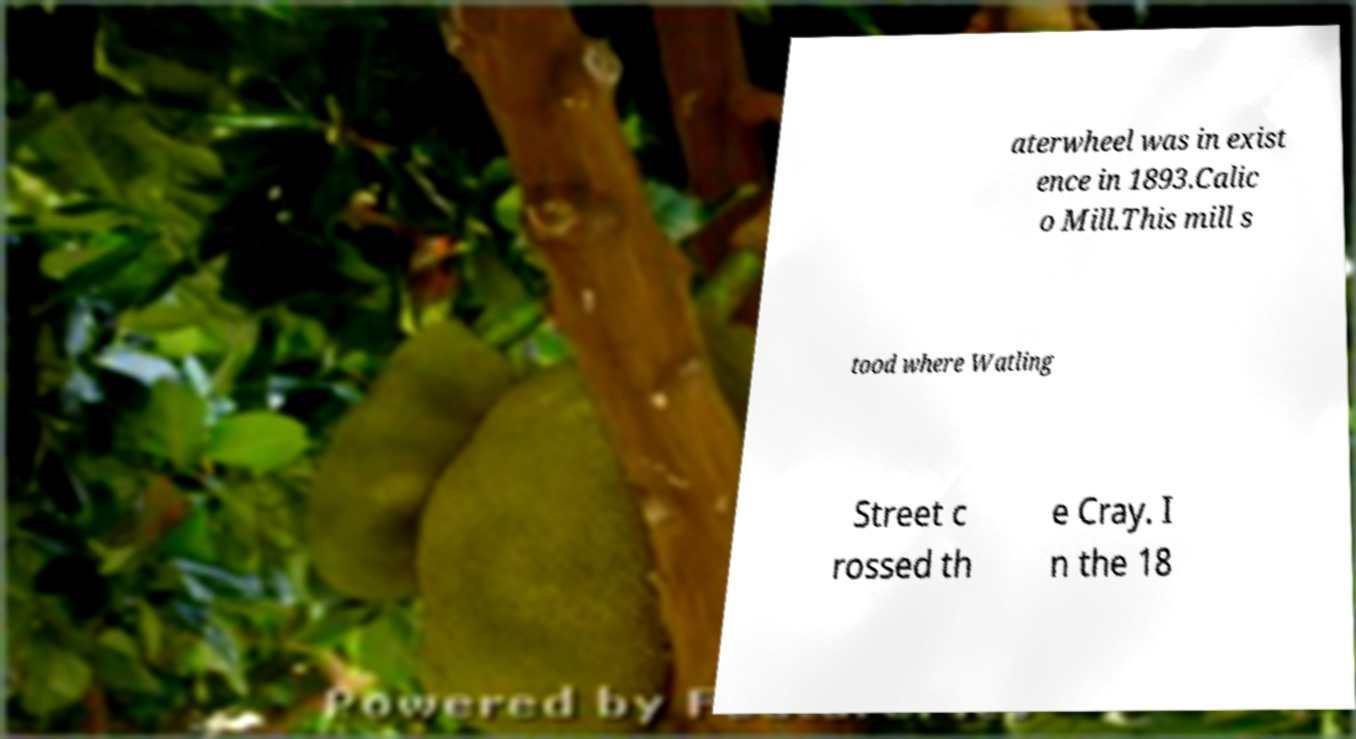What messages or text are displayed in this image? I need them in a readable, typed format. aterwheel was in exist ence in 1893.Calic o Mill.This mill s tood where Watling Street c rossed th e Cray. I n the 18 